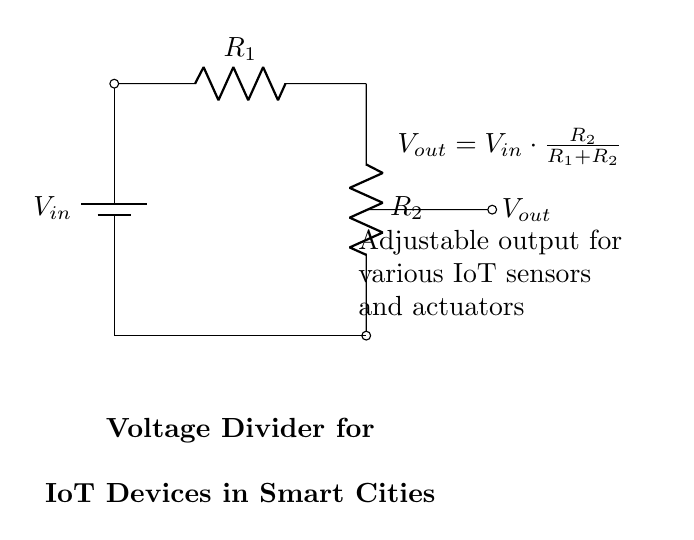What are the two resistors in this voltage divider? The circuit diagram shows two resistors labeled as R1 and R2. These resistors are connected in series, and they are responsible for dividing the input voltage.
Answer: R1, R2 What is the formula for the output voltage? The output voltage is given by the equation \( V_{out} = V_{in} \cdot \frac{R_2}{R_1 + R_2} \), which means the output voltage depends on the input voltage and the ratio of the resistors.
Answer: Vout = Vin * (R2 / (R1 + R2)) What is the function of R1 in the circuit? R1 is one of the two resistors in the voltage divider and it plays a critical role in determining how much voltage is dropped across it compared to R2. It influences the division of the total input voltage between both resistors.
Answer: Voltage drop What is the purpose of this voltage divider in smart city initiatives? The voltage divider is used to provide an adjustable output voltage suitable for powering various IoT sensors and actuators, ensuring that these devices receive the appropriate voltage for their operation.
Answer: Powering IoT devices If R1 is increased while R2 remains constant, what happens to Vout? Increasing R1 increases the total resistance in the circuit, leading to a decrease in output voltage (Vout) because it alters the resistor ratio in the formula. This can be understood by observing that a higher R1 in the equation decreases the fraction fed to Vout.
Answer: Vout decreases What does Vout depend on in this circuit? Vout relies on the ratio of the resistances R1 and R2 relative to the input voltage (Vin). Specifically, it is dependent on the respective values of these resistors, as well as the magnitude of the input voltage.
Answer: R1, R2, Vin What advantages does an adjustable output provide for IoT devices? An adjustable output allows flexibility in powering different devices that may require specific voltage levels, optimizing performance and energy efficiency for various sensors and actuators used in smart city applications.
Answer: Flexibility 